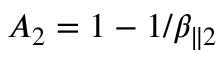<formula> <loc_0><loc_0><loc_500><loc_500>A _ { 2 } = 1 - 1 / \beta _ { \| 2 }</formula> 